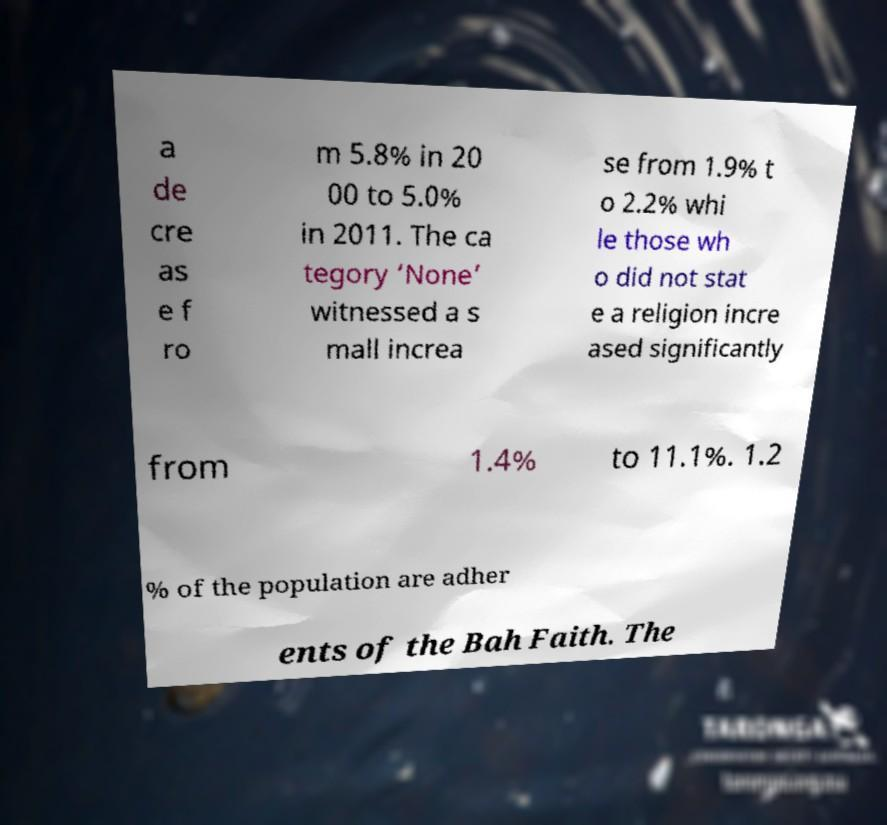Please read and relay the text visible in this image. What does it say? a de cre as e f ro m 5.8% in 20 00 to 5.0% in 2011. The ca tegory ‘None’ witnessed a s mall increa se from 1.9% t o 2.2% whi le those wh o did not stat e a religion incre ased significantly from 1.4% to 11.1%. 1.2 % of the population are adher ents of the Bah Faith. The 